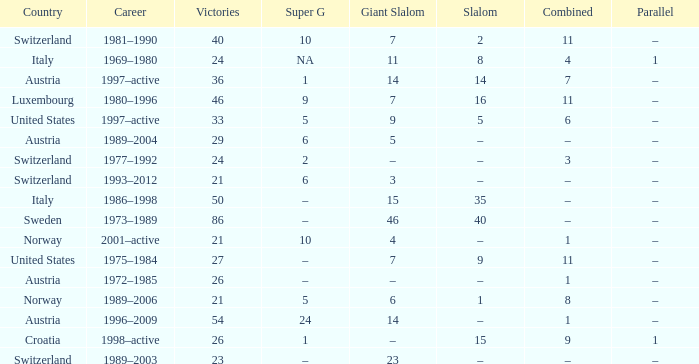What Country has a Career of 1989–2004? Austria. 